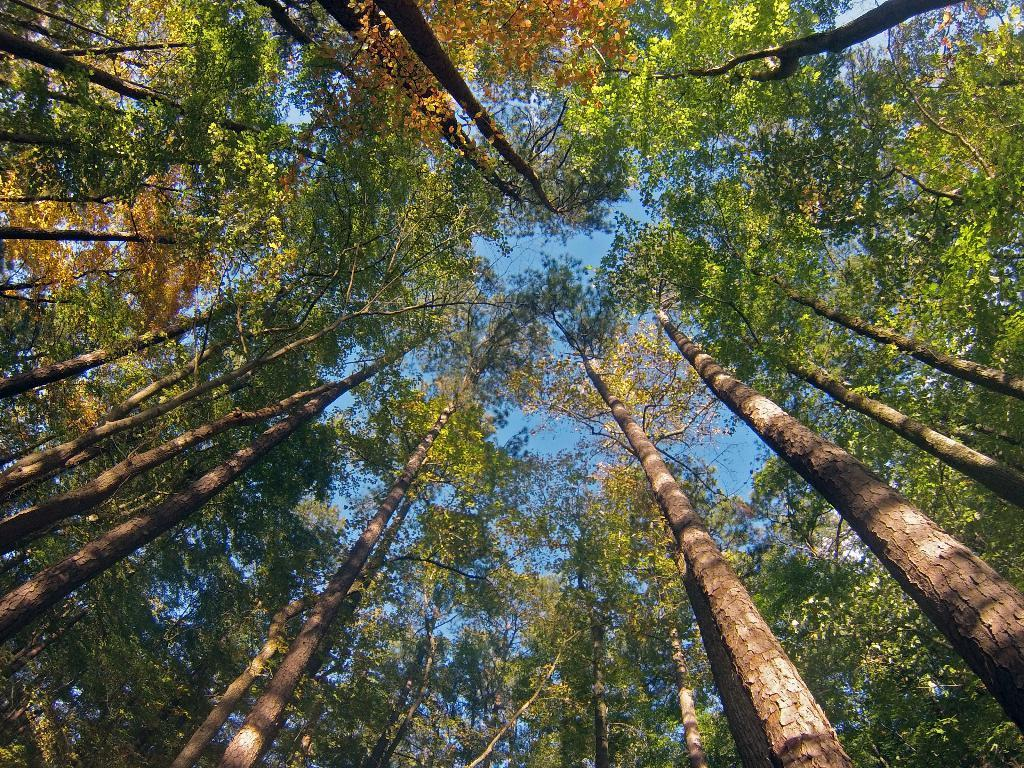What type of vegetation can be seen in the image? There are many trees in the image. What part of the natural environment is visible in the image? The sky is visible in the background of the image. What type of vegetable is growing on the trees in the image? There are no vegetables visible on the trees in the image; they are simply trees. 